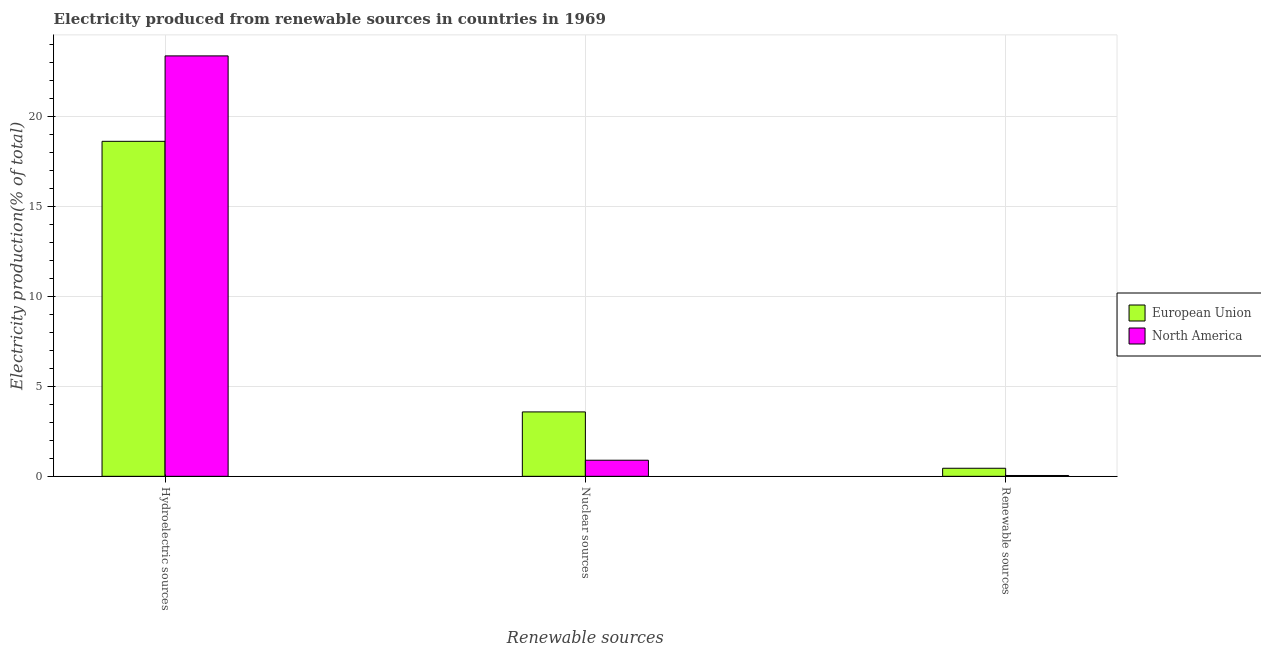How many different coloured bars are there?
Make the answer very short. 2. Are the number of bars per tick equal to the number of legend labels?
Your answer should be very brief. Yes. How many bars are there on the 2nd tick from the left?
Provide a succinct answer. 2. How many bars are there on the 1st tick from the right?
Give a very brief answer. 2. What is the label of the 2nd group of bars from the left?
Offer a very short reply. Nuclear sources. What is the percentage of electricity produced by renewable sources in European Union?
Your answer should be very brief. 0.45. Across all countries, what is the maximum percentage of electricity produced by hydroelectric sources?
Offer a terse response. 23.39. Across all countries, what is the minimum percentage of electricity produced by renewable sources?
Offer a very short reply. 0.05. In which country was the percentage of electricity produced by hydroelectric sources maximum?
Keep it short and to the point. North America. In which country was the percentage of electricity produced by renewable sources minimum?
Your response must be concise. North America. What is the total percentage of electricity produced by hydroelectric sources in the graph?
Offer a terse response. 42.03. What is the difference between the percentage of electricity produced by renewable sources in North America and that in European Union?
Offer a very short reply. -0.4. What is the difference between the percentage of electricity produced by renewable sources in North America and the percentage of electricity produced by nuclear sources in European Union?
Make the answer very short. -3.54. What is the average percentage of electricity produced by hydroelectric sources per country?
Give a very brief answer. 21.01. What is the difference between the percentage of electricity produced by nuclear sources and percentage of electricity produced by hydroelectric sources in European Union?
Your response must be concise. -15.05. What is the ratio of the percentage of electricity produced by nuclear sources in European Union to that in North America?
Make the answer very short. 4. What is the difference between the highest and the second highest percentage of electricity produced by renewable sources?
Your answer should be compact. 0.4. What is the difference between the highest and the lowest percentage of electricity produced by nuclear sources?
Your response must be concise. 2.69. In how many countries, is the percentage of electricity produced by nuclear sources greater than the average percentage of electricity produced by nuclear sources taken over all countries?
Your response must be concise. 1. Is the sum of the percentage of electricity produced by hydroelectric sources in North America and European Union greater than the maximum percentage of electricity produced by nuclear sources across all countries?
Give a very brief answer. Yes. What does the 1st bar from the left in Nuclear sources represents?
Ensure brevity in your answer.  European Union. How many bars are there?
Your answer should be very brief. 6. How many countries are there in the graph?
Give a very brief answer. 2. Are the values on the major ticks of Y-axis written in scientific E-notation?
Keep it short and to the point. No. Does the graph contain any zero values?
Provide a short and direct response. No. Where does the legend appear in the graph?
Your response must be concise. Center right. How many legend labels are there?
Offer a very short reply. 2. What is the title of the graph?
Ensure brevity in your answer.  Electricity produced from renewable sources in countries in 1969. Does "Egypt, Arab Rep." appear as one of the legend labels in the graph?
Your answer should be very brief. No. What is the label or title of the X-axis?
Make the answer very short. Renewable sources. What is the label or title of the Y-axis?
Offer a very short reply. Electricity production(% of total). What is the Electricity production(% of total) in European Union in Hydroelectric sources?
Offer a terse response. 18.64. What is the Electricity production(% of total) of North America in Hydroelectric sources?
Keep it short and to the point. 23.39. What is the Electricity production(% of total) in European Union in Nuclear sources?
Provide a succinct answer. 3.58. What is the Electricity production(% of total) in North America in Nuclear sources?
Your answer should be very brief. 0.9. What is the Electricity production(% of total) of European Union in Renewable sources?
Offer a terse response. 0.45. What is the Electricity production(% of total) of North America in Renewable sources?
Keep it short and to the point. 0.05. Across all Renewable sources, what is the maximum Electricity production(% of total) of European Union?
Keep it short and to the point. 18.64. Across all Renewable sources, what is the maximum Electricity production(% of total) in North America?
Your answer should be compact. 23.39. Across all Renewable sources, what is the minimum Electricity production(% of total) in European Union?
Ensure brevity in your answer.  0.45. Across all Renewable sources, what is the minimum Electricity production(% of total) in North America?
Make the answer very short. 0.05. What is the total Electricity production(% of total) of European Union in the graph?
Your answer should be very brief. 22.67. What is the total Electricity production(% of total) of North America in the graph?
Ensure brevity in your answer.  24.33. What is the difference between the Electricity production(% of total) of European Union in Hydroelectric sources and that in Nuclear sources?
Give a very brief answer. 15.05. What is the difference between the Electricity production(% of total) in North America in Hydroelectric sources and that in Nuclear sources?
Make the answer very short. 22.49. What is the difference between the Electricity production(% of total) in European Union in Hydroelectric sources and that in Renewable sources?
Keep it short and to the point. 18.19. What is the difference between the Electricity production(% of total) of North America in Hydroelectric sources and that in Renewable sources?
Offer a very short reply. 23.34. What is the difference between the Electricity production(% of total) in European Union in Nuclear sources and that in Renewable sources?
Your response must be concise. 3.13. What is the difference between the Electricity production(% of total) in North America in Nuclear sources and that in Renewable sources?
Offer a very short reply. 0.85. What is the difference between the Electricity production(% of total) of European Union in Hydroelectric sources and the Electricity production(% of total) of North America in Nuclear sources?
Your answer should be compact. 17.74. What is the difference between the Electricity production(% of total) of European Union in Hydroelectric sources and the Electricity production(% of total) of North America in Renewable sources?
Make the answer very short. 18.59. What is the difference between the Electricity production(% of total) of European Union in Nuclear sources and the Electricity production(% of total) of North America in Renewable sources?
Make the answer very short. 3.54. What is the average Electricity production(% of total) of European Union per Renewable sources?
Offer a terse response. 7.56. What is the average Electricity production(% of total) in North America per Renewable sources?
Ensure brevity in your answer.  8.11. What is the difference between the Electricity production(% of total) in European Union and Electricity production(% of total) in North America in Hydroelectric sources?
Provide a succinct answer. -4.75. What is the difference between the Electricity production(% of total) in European Union and Electricity production(% of total) in North America in Nuclear sources?
Ensure brevity in your answer.  2.69. What is the difference between the Electricity production(% of total) in European Union and Electricity production(% of total) in North America in Renewable sources?
Your answer should be very brief. 0.4. What is the ratio of the Electricity production(% of total) of European Union in Hydroelectric sources to that in Nuclear sources?
Your response must be concise. 5.2. What is the ratio of the Electricity production(% of total) in North America in Hydroelectric sources to that in Nuclear sources?
Offer a very short reply. 26.12. What is the ratio of the Electricity production(% of total) in European Union in Hydroelectric sources to that in Renewable sources?
Your answer should be very brief. 41.6. What is the ratio of the Electricity production(% of total) in North America in Hydroelectric sources to that in Renewable sources?
Provide a short and direct response. 504.55. What is the ratio of the Electricity production(% of total) in European Union in Nuclear sources to that in Renewable sources?
Offer a very short reply. 8. What is the ratio of the Electricity production(% of total) in North America in Nuclear sources to that in Renewable sources?
Ensure brevity in your answer.  19.31. What is the difference between the highest and the second highest Electricity production(% of total) in European Union?
Make the answer very short. 15.05. What is the difference between the highest and the second highest Electricity production(% of total) in North America?
Your answer should be very brief. 22.49. What is the difference between the highest and the lowest Electricity production(% of total) in European Union?
Your answer should be very brief. 18.19. What is the difference between the highest and the lowest Electricity production(% of total) in North America?
Offer a very short reply. 23.34. 